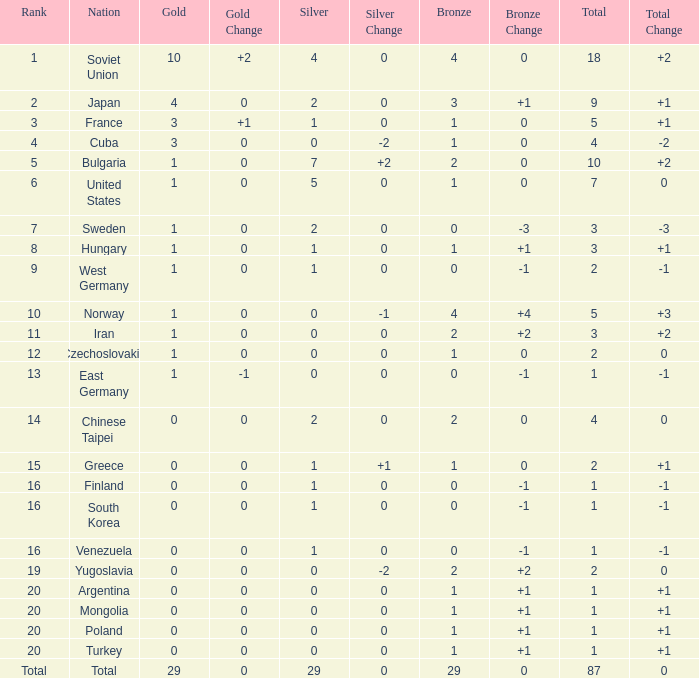What is the sum of gold medals for a rank of 14? 0.0. 